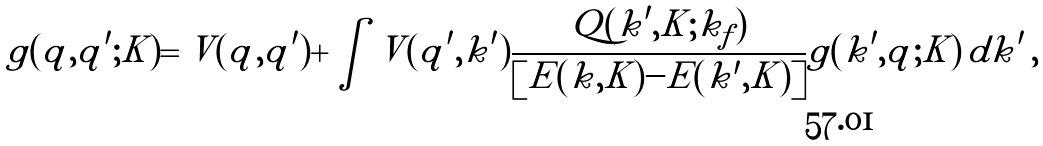<formula> <loc_0><loc_0><loc_500><loc_500>g ( q , q ^ { \prime } ; K ) = V ( q , q ^ { \prime } ) + \int V ( q ^ { \prime } , k ^ { \prime } ) \frac { Q ( k ^ { \prime } , K ; k _ { f } ) } { \left [ E ( k , K ) - E ( k ^ { \prime } , K ) \right ] } g ( k ^ { \prime } , q ; K ) \, d k ^ { \prime } \, ,</formula> 